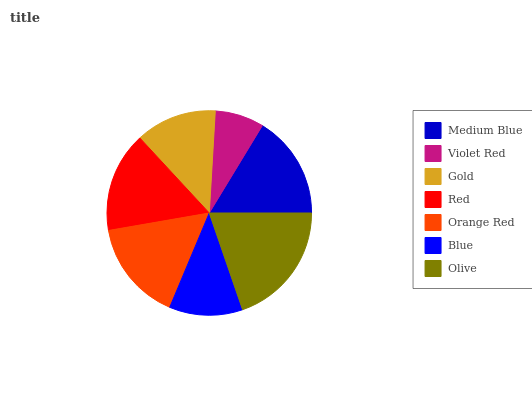Is Violet Red the minimum?
Answer yes or no. Yes. Is Olive the maximum?
Answer yes or no. Yes. Is Gold the minimum?
Answer yes or no. No. Is Gold the maximum?
Answer yes or no. No. Is Gold greater than Violet Red?
Answer yes or no. Yes. Is Violet Red less than Gold?
Answer yes or no. Yes. Is Violet Red greater than Gold?
Answer yes or no. No. Is Gold less than Violet Red?
Answer yes or no. No. Is Red the high median?
Answer yes or no. Yes. Is Red the low median?
Answer yes or no. Yes. Is Violet Red the high median?
Answer yes or no. No. Is Olive the low median?
Answer yes or no. No. 